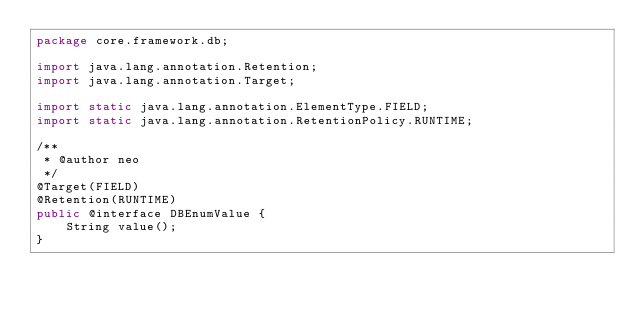Convert code to text. <code><loc_0><loc_0><loc_500><loc_500><_Java_>package core.framework.db;

import java.lang.annotation.Retention;
import java.lang.annotation.Target;

import static java.lang.annotation.ElementType.FIELD;
import static java.lang.annotation.RetentionPolicy.RUNTIME;

/**
 * @author neo
 */
@Target(FIELD)
@Retention(RUNTIME)
public @interface DBEnumValue {
    String value();
}
</code> 